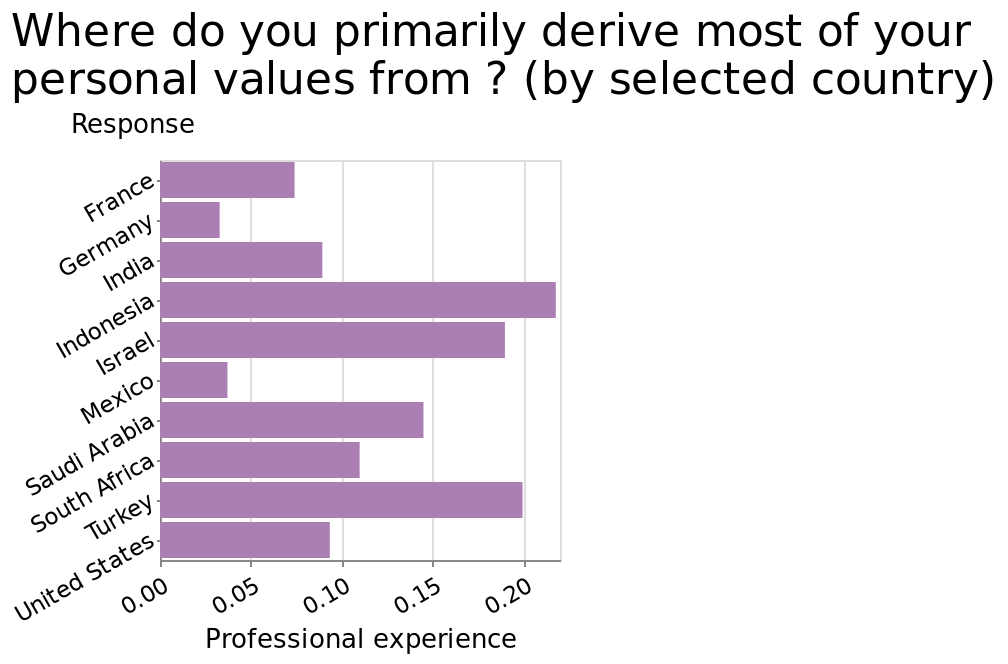<image>
please summary the statistics and relations of the chart That's some countries hold personal values greater than others. What does the x-axis of the bar graph represent? The x-axis of the bar graph represents the range of professional experience, ranging from 0.00 to 0.20. How are the countries represented on the y-axis of the bar graph? The countries are represented on the y-axis of the bar graph using a categorical scale from France to United States. 